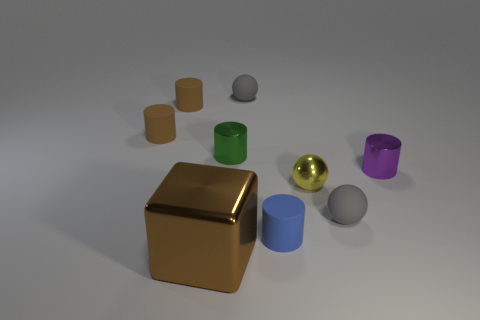What is the shape of the small green object that is the same material as the yellow object?
Ensure brevity in your answer.  Cylinder. Are there any other things that are the same color as the big cube?
Make the answer very short. Yes. Is the number of tiny rubber spheres in front of the small purple shiny cylinder greater than the number of brown rubber balls?
Provide a succinct answer. Yes. What material is the tiny yellow object?
Offer a terse response. Metal. How many gray rubber blocks have the same size as the purple thing?
Provide a succinct answer. 0. Are there an equal number of brown metallic objects that are right of the blue object and metal cylinders right of the tiny yellow metal thing?
Keep it short and to the point. No. Is the material of the tiny purple cylinder the same as the brown cube?
Make the answer very short. Yes. There is a tiny matte cylinder that is to the right of the big metallic cube; are there any tiny metal objects in front of it?
Your response must be concise. No. Is there a big blue shiny thing that has the same shape as the small green thing?
Make the answer very short. No. Is the metal sphere the same color as the large thing?
Provide a short and direct response. No. 